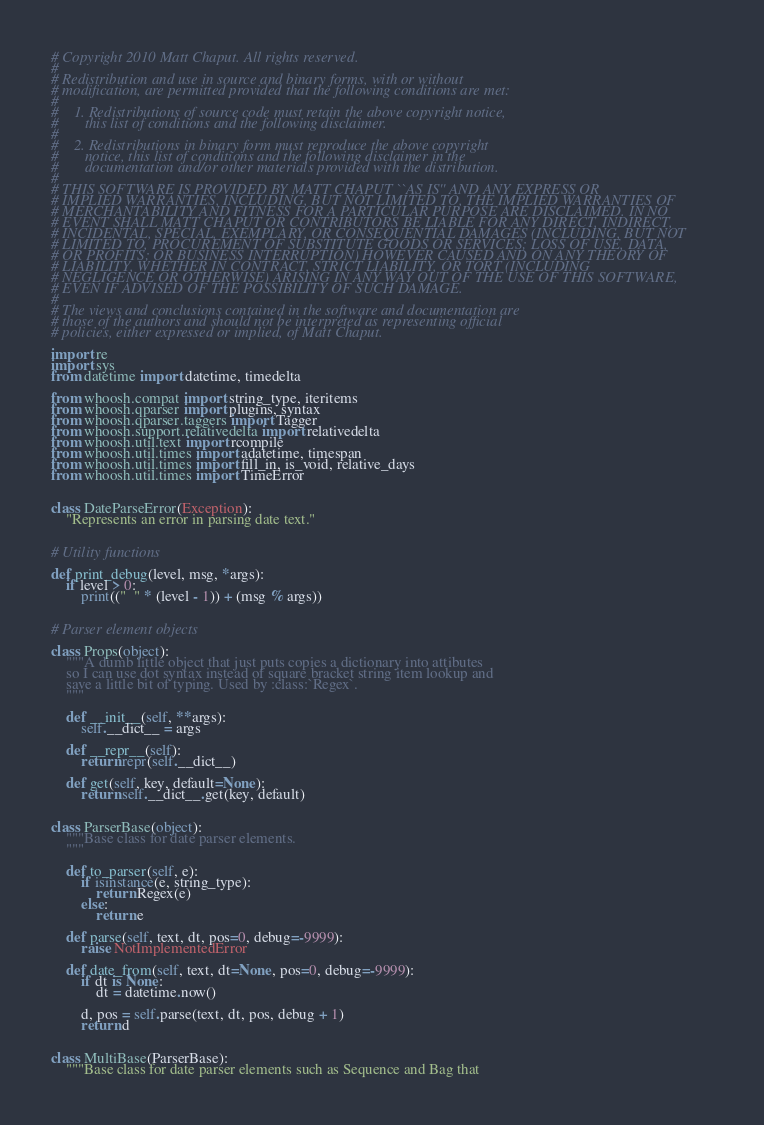Convert code to text. <code><loc_0><loc_0><loc_500><loc_500><_Python_># Copyright 2010 Matt Chaput. All rights reserved.
#
# Redistribution and use in source and binary forms, with or without
# modification, are permitted provided that the following conditions are met:
#
#    1. Redistributions of source code must retain the above copyright notice,
#       this list of conditions and the following disclaimer.
#
#    2. Redistributions in binary form must reproduce the above copyright
#       notice, this list of conditions and the following disclaimer in the
#       documentation and/or other materials provided with the distribution.
#
# THIS SOFTWARE IS PROVIDED BY MATT CHAPUT ``AS IS'' AND ANY EXPRESS OR
# IMPLIED WARRANTIES, INCLUDING, BUT NOT LIMITED TO, THE IMPLIED WARRANTIES OF
# MERCHANTABILITY AND FITNESS FOR A PARTICULAR PURPOSE ARE DISCLAIMED. IN NO
# EVENT SHALL MATT CHAPUT OR CONTRIBUTORS BE LIABLE FOR ANY DIRECT, INDIRECT,
# INCIDENTAL, SPECIAL, EXEMPLARY, OR CONSEQUENTIAL DAMAGES (INCLUDING, BUT NOT
# LIMITED TO, PROCUREMENT OF SUBSTITUTE GOODS OR SERVICES; LOSS OF USE, DATA,
# OR PROFITS; OR BUSINESS INTERRUPTION) HOWEVER CAUSED AND ON ANY THEORY OF
# LIABILITY, WHETHER IN CONTRACT, STRICT LIABILITY, OR TORT (INCLUDING
# NEGLIGENCE OR OTHERWISE) ARISING IN ANY WAY OUT OF THE USE OF THIS SOFTWARE,
# EVEN IF ADVISED OF THE POSSIBILITY OF SUCH DAMAGE.
#
# The views and conclusions contained in the software and documentation are
# those of the authors and should not be interpreted as representing official
# policies, either expressed or implied, of Matt Chaput.

import re
import sys
from datetime import datetime, timedelta

from whoosh.compat import string_type, iteritems
from whoosh.qparser import plugins, syntax
from whoosh.qparser.taggers import Tagger
from whoosh.support.relativedelta import relativedelta
from whoosh.util.text import rcompile
from whoosh.util.times import adatetime, timespan
from whoosh.util.times import fill_in, is_void, relative_days
from whoosh.util.times import TimeError


class DateParseError(Exception):
    "Represents an error in parsing date text."


# Utility functions

def print_debug(level, msg, *args):
    if level > 0:
        print(("  " * (level - 1)) + (msg % args))


# Parser element objects

class Props(object):
    """A dumb little object that just puts copies a dictionary into attibutes
    so I can use dot syntax instead of square bracket string item lookup and
    save a little bit of typing. Used by :class:`Regex`.
    """

    def __init__(self, **args):
        self.__dict__ = args

    def __repr__(self):
        return repr(self.__dict__)

    def get(self, key, default=None):
        return self.__dict__.get(key, default)


class ParserBase(object):
    """Base class for date parser elements.
    """

    def to_parser(self, e):
        if isinstance(e, string_type):
            return Regex(e)
        else:
            return e

    def parse(self, text, dt, pos=0, debug=-9999):
        raise NotImplementedError

    def date_from(self, text, dt=None, pos=0, debug=-9999):
        if dt is None:
            dt = datetime.now()

        d, pos = self.parse(text, dt, pos, debug + 1)
        return d


class MultiBase(ParserBase):
    """Base class for date parser elements such as Sequence and Bag that</code> 